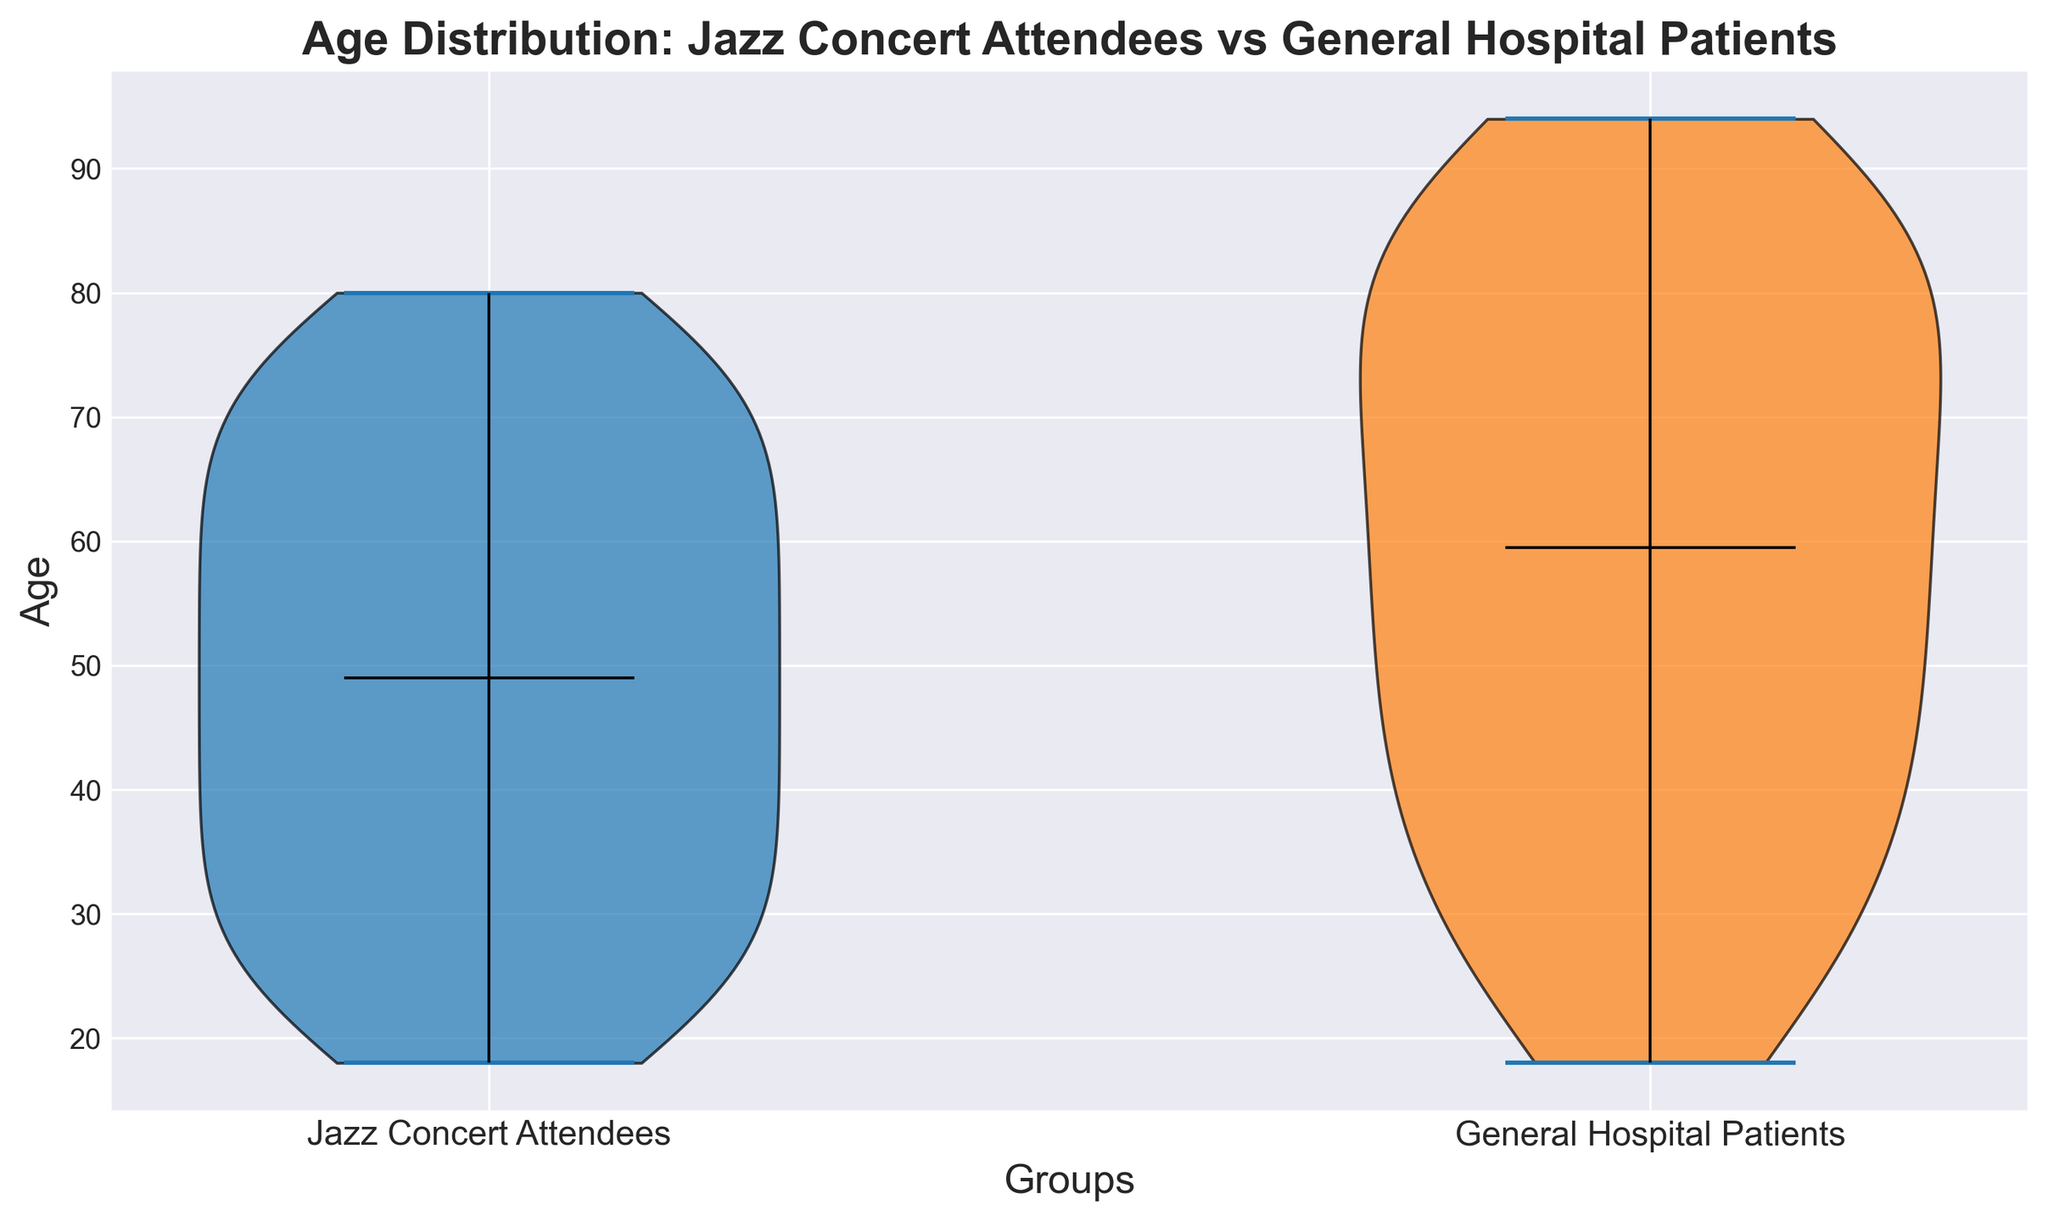What are the median ages of jazz concert attendees and general hospital patients? To answer this, examine the center line of the violin plots for each group, which represents the median age. Read the corresponding value from the y-axis for both plots.
Answer: Jazz Concert Attendees: 49.5, General Hospital Patients: 62 Which group has a more spread age distribution? The spread can be determined by the width and length of the violin plots. Wider and longer plots indicate a more spread age distribution.
Answer: General Hospital Patients Is there any overlap in the age distribution of the two groups? Look at the range of the violin plots and see if they intersect. Both groups share some age ranges, so overlap is present.
Answer: Yes Which group has a younger age population? Examine the lower part of each violin plot. The group with the lower starting point on the y-axis represents the younger population.
Answer: Jazz Concert Attendees Are there any outliers in the age distributions of the groups? Outliers in a violin plot are typically indicated by points or extended tails far from the central mass of the distribution. There are no explicit points shown, but the range can indicate outliers.
Answer: No explicit outliers What is the age range of jazz concert attendees? Identify the highest and lowest points of the violin plot for jazz concert attendees to determine the range.
Answer: 18 to 80 Which group has a higher median age? Compare the central lines of the violin plots; the group with the higher line has the higher median age.
Answer: General Hospital Patients What is the average age of attendees if the median is known to be around 50? Given the median, one can infer the average if the distribution is roughly symmetrical. For more accuracy, detailed numerical calculations of all data points are necessary, but visual estimation from a violin plot is possible.
Answer: Approximately 50 (assuming symmetry) How do the upper quartiles of the age distributions compare between the two groups? The upper quartile is represented by the top 25% of the range in a violin plot. Compare the relative heights from the median to the top of each plot.
Answer: General Hospital Patients have a higher upper quartile From a visual perspective, which group appears to have attendees who are mostly middle-aged? By identifying the concentration of the wider portion (bulk) of the violin plot, one can determine where most individuals fall age-wise.
Answer: Jazz Concert Attendees 